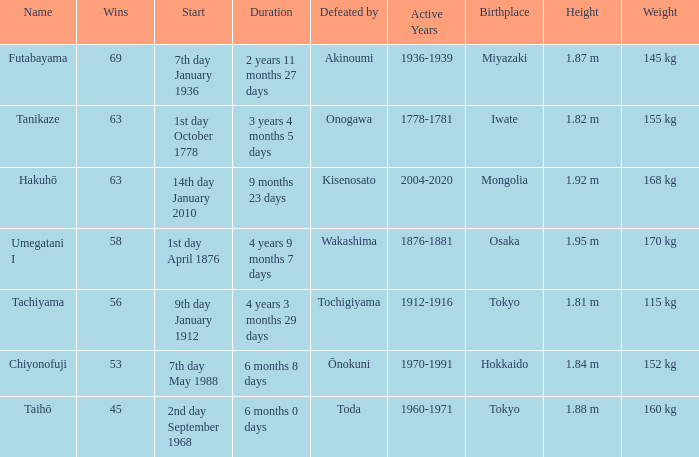What is the Duration for less than 53 consecutive wins? 6 months 0 days. 